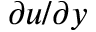<formula> <loc_0><loc_0><loc_500><loc_500>\partial u / \partial y</formula> 